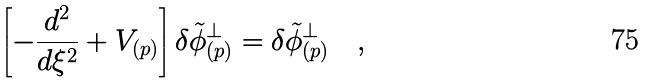<formula> <loc_0><loc_0><loc_500><loc_500>\left [ - { \frac { d ^ { 2 } } { d \xi ^ { 2 } } } + V _ { ( p ) } \right ] \delta { \tilde { \phi } } ^ { \perp } _ { ( p ) } = \delta { \tilde { \phi } } ^ { \perp } _ { ( p ) } \quad ,</formula> 